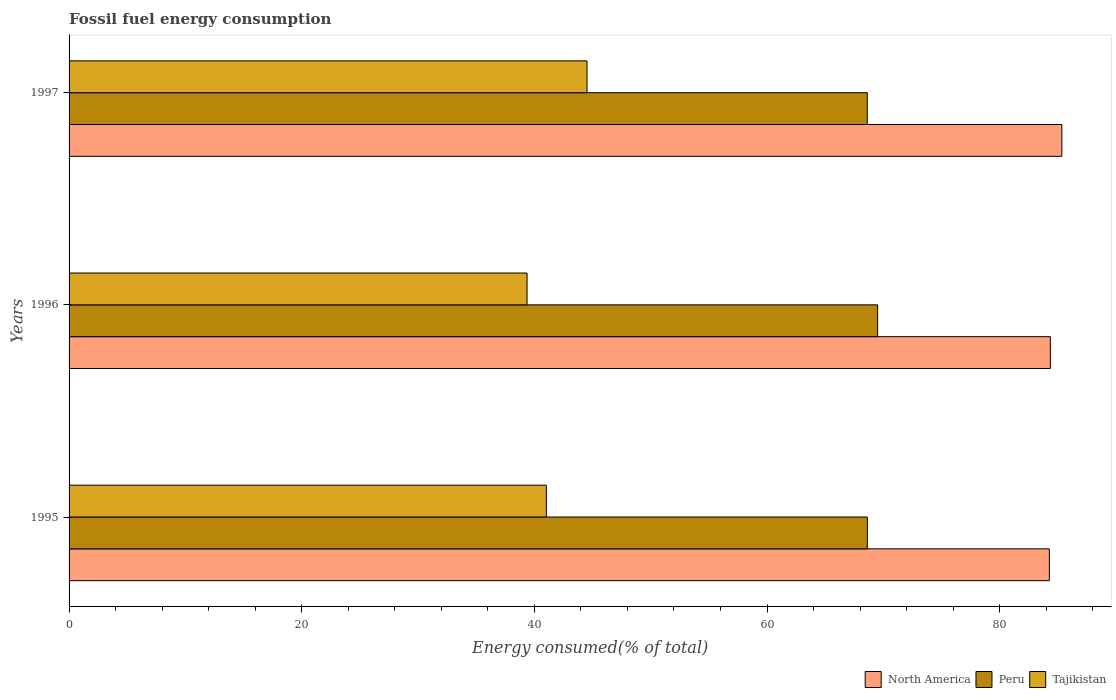How many different coloured bars are there?
Ensure brevity in your answer.  3. Are the number of bars on each tick of the Y-axis equal?
Keep it short and to the point. Yes. What is the percentage of energy consumed in Tajikistan in 1997?
Your answer should be compact. 44.52. Across all years, what is the maximum percentage of energy consumed in Tajikistan?
Provide a succinct answer. 44.52. Across all years, what is the minimum percentage of energy consumed in Tajikistan?
Give a very brief answer. 39.37. In which year was the percentage of energy consumed in North America maximum?
Ensure brevity in your answer.  1997. In which year was the percentage of energy consumed in North America minimum?
Your response must be concise. 1995. What is the total percentage of energy consumed in Tajikistan in the graph?
Provide a short and direct response. 124.92. What is the difference between the percentage of energy consumed in Peru in 1995 and that in 1996?
Keep it short and to the point. -0.88. What is the difference between the percentage of energy consumed in Tajikistan in 1996 and the percentage of energy consumed in North America in 1995?
Ensure brevity in your answer.  -44.9. What is the average percentage of energy consumed in Tajikistan per year?
Your answer should be compact. 41.64. In the year 1995, what is the difference between the percentage of energy consumed in Tajikistan and percentage of energy consumed in North America?
Ensure brevity in your answer.  -43.24. What is the ratio of the percentage of energy consumed in Tajikistan in 1996 to that in 1997?
Your response must be concise. 0.88. Is the percentage of energy consumed in Peru in 1995 less than that in 1996?
Offer a terse response. Yes. What is the difference between the highest and the second highest percentage of energy consumed in Tajikistan?
Offer a terse response. 3.5. What is the difference between the highest and the lowest percentage of energy consumed in Peru?
Keep it short and to the point. 0.89. In how many years, is the percentage of energy consumed in North America greater than the average percentage of energy consumed in North America taken over all years?
Offer a very short reply. 1. How many bars are there?
Keep it short and to the point. 9. What is the difference between two consecutive major ticks on the X-axis?
Provide a succinct answer. 20. Does the graph contain any zero values?
Offer a terse response. No. How are the legend labels stacked?
Your answer should be very brief. Horizontal. What is the title of the graph?
Offer a very short reply. Fossil fuel energy consumption. Does "Zambia" appear as one of the legend labels in the graph?
Give a very brief answer. No. What is the label or title of the X-axis?
Your answer should be compact. Energy consumed(% of total). What is the label or title of the Y-axis?
Your answer should be very brief. Years. What is the Energy consumed(% of total) in North America in 1995?
Offer a very short reply. 84.27. What is the Energy consumed(% of total) in Peru in 1995?
Ensure brevity in your answer.  68.62. What is the Energy consumed(% of total) in Tajikistan in 1995?
Your answer should be compact. 41.03. What is the Energy consumed(% of total) of North America in 1996?
Provide a succinct answer. 84.35. What is the Energy consumed(% of total) in Peru in 1996?
Your response must be concise. 69.5. What is the Energy consumed(% of total) in Tajikistan in 1996?
Offer a terse response. 39.37. What is the Energy consumed(% of total) in North America in 1997?
Offer a terse response. 85.34. What is the Energy consumed(% of total) of Peru in 1997?
Give a very brief answer. 68.62. What is the Energy consumed(% of total) of Tajikistan in 1997?
Keep it short and to the point. 44.52. Across all years, what is the maximum Energy consumed(% of total) in North America?
Give a very brief answer. 85.34. Across all years, what is the maximum Energy consumed(% of total) in Peru?
Offer a very short reply. 69.5. Across all years, what is the maximum Energy consumed(% of total) of Tajikistan?
Provide a succinct answer. 44.52. Across all years, what is the minimum Energy consumed(% of total) in North America?
Offer a very short reply. 84.27. Across all years, what is the minimum Energy consumed(% of total) of Peru?
Make the answer very short. 68.62. Across all years, what is the minimum Energy consumed(% of total) in Tajikistan?
Your response must be concise. 39.37. What is the total Energy consumed(% of total) in North America in the graph?
Give a very brief answer. 253.96. What is the total Energy consumed(% of total) in Peru in the graph?
Provide a short and direct response. 206.74. What is the total Energy consumed(% of total) in Tajikistan in the graph?
Your answer should be very brief. 124.92. What is the difference between the Energy consumed(% of total) in North America in 1995 and that in 1996?
Your answer should be very brief. -0.08. What is the difference between the Energy consumed(% of total) in Peru in 1995 and that in 1996?
Make the answer very short. -0.88. What is the difference between the Energy consumed(% of total) in Tajikistan in 1995 and that in 1996?
Your response must be concise. 1.66. What is the difference between the Energy consumed(% of total) of North America in 1995 and that in 1997?
Give a very brief answer. -1.08. What is the difference between the Energy consumed(% of total) in Peru in 1995 and that in 1997?
Provide a succinct answer. 0.01. What is the difference between the Energy consumed(% of total) in Tajikistan in 1995 and that in 1997?
Provide a short and direct response. -3.5. What is the difference between the Energy consumed(% of total) of North America in 1996 and that in 1997?
Give a very brief answer. -0.99. What is the difference between the Energy consumed(% of total) of Peru in 1996 and that in 1997?
Provide a short and direct response. 0.89. What is the difference between the Energy consumed(% of total) in Tajikistan in 1996 and that in 1997?
Your answer should be compact. -5.15. What is the difference between the Energy consumed(% of total) of North America in 1995 and the Energy consumed(% of total) of Peru in 1996?
Give a very brief answer. 14.76. What is the difference between the Energy consumed(% of total) of North America in 1995 and the Energy consumed(% of total) of Tajikistan in 1996?
Provide a succinct answer. 44.9. What is the difference between the Energy consumed(% of total) of Peru in 1995 and the Energy consumed(% of total) of Tajikistan in 1996?
Your answer should be very brief. 29.25. What is the difference between the Energy consumed(% of total) of North America in 1995 and the Energy consumed(% of total) of Peru in 1997?
Offer a terse response. 15.65. What is the difference between the Energy consumed(% of total) of North America in 1995 and the Energy consumed(% of total) of Tajikistan in 1997?
Offer a terse response. 39.74. What is the difference between the Energy consumed(% of total) of Peru in 1995 and the Energy consumed(% of total) of Tajikistan in 1997?
Make the answer very short. 24.1. What is the difference between the Energy consumed(% of total) of North America in 1996 and the Energy consumed(% of total) of Peru in 1997?
Your answer should be very brief. 15.73. What is the difference between the Energy consumed(% of total) in North America in 1996 and the Energy consumed(% of total) in Tajikistan in 1997?
Make the answer very short. 39.83. What is the difference between the Energy consumed(% of total) of Peru in 1996 and the Energy consumed(% of total) of Tajikistan in 1997?
Your answer should be compact. 24.98. What is the average Energy consumed(% of total) in North America per year?
Keep it short and to the point. 84.65. What is the average Energy consumed(% of total) in Peru per year?
Offer a terse response. 68.91. What is the average Energy consumed(% of total) of Tajikistan per year?
Give a very brief answer. 41.64. In the year 1995, what is the difference between the Energy consumed(% of total) of North America and Energy consumed(% of total) of Peru?
Your answer should be very brief. 15.64. In the year 1995, what is the difference between the Energy consumed(% of total) in North America and Energy consumed(% of total) in Tajikistan?
Your answer should be very brief. 43.24. In the year 1995, what is the difference between the Energy consumed(% of total) of Peru and Energy consumed(% of total) of Tajikistan?
Give a very brief answer. 27.6. In the year 1996, what is the difference between the Energy consumed(% of total) of North America and Energy consumed(% of total) of Peru?
Your response must be concise. 14.85. In the year 1996, what is the difference between the Energy consumed(% of total) of North America and Energy consumed(% of total) of Tajikistan?
Your answer should be compact. 44.98. In the year 1996, what is the difference between the Energy consumed(% of total) of Peru and Energy consumed(% of total) of Tajikistan?
Give a very brief answer. 30.13. In the year 1997, what is the difference between the Energy consumed(% of total) in North America and Energy consumed(% of total) in Peru?
Keep it short and to the point. 16.72. In the year 1997, what is the difference between the Energy consumed(% of total) in North America and Energy consumed(% of total) in Tajikistan?
Make the answer very short. 40.82. In the year 1997, what is the difference between the Energy consumed(% of total) of Peru and Energy consumed(% of total) of Tajikistan?
Keep it short and to the point. 24.09. What is the ratio of the Energy consumed(% of total) in Peru in 1995 to that in 1996?
Provide a short and direct response. 0.99. What is the ratio of the Energy consumed(% of total) in Tajikistan in 1995 to that in 1996?
Offer a terse response. 1.04. What is the ratio of the Energy consumed(% of total) of North America in 1995 to that in 1997?
Make the answer very short. 0.99. What is the ratio of the Energy consumed(% of total) of Peru in 1995 to that in 1997?
Provide a short and direct response. 1. What is the ratio of the Energy consumed(% of total) of Tajikistan in 1995 to that in 1997?
Offer a very short reply. 0.92. What is the ratio of the Energy consumed(% of total) in North America in 1996 to that in 1997?
Ensure brevity in your answer.  0.99. What is the ratio of the Energy consumed(% of total) in Peru in 1996 to that in 1997?
Make the answer very short. 1.01. What is the ratio of the Energy consumed(% of total) of Tajikistan in 1996 to that in 1997?
Ensure brevity in your answer.  0.88. What is the difference between the highest and the second highest Energy consumed(% of total) in Peru?
Your answer should be compact. 0.88. What is the difference between the highest and the second highest Energy consumed(% of total) in Tajikistan?
Provide a short and direct response. 3.5. What is the difference between the highest and the lowest Energy consumed(% of total) of North America?
Provide a succinct answer. 1.08. What is the difference between the highest and the lowest Energy consumed(% of total) in Peru?
Make the answer very short. 0.89. What is the difference between the highest and the lowest Energy consumed(% of total) in Tajikistan?
Provide a succinct answer. 5.15. 